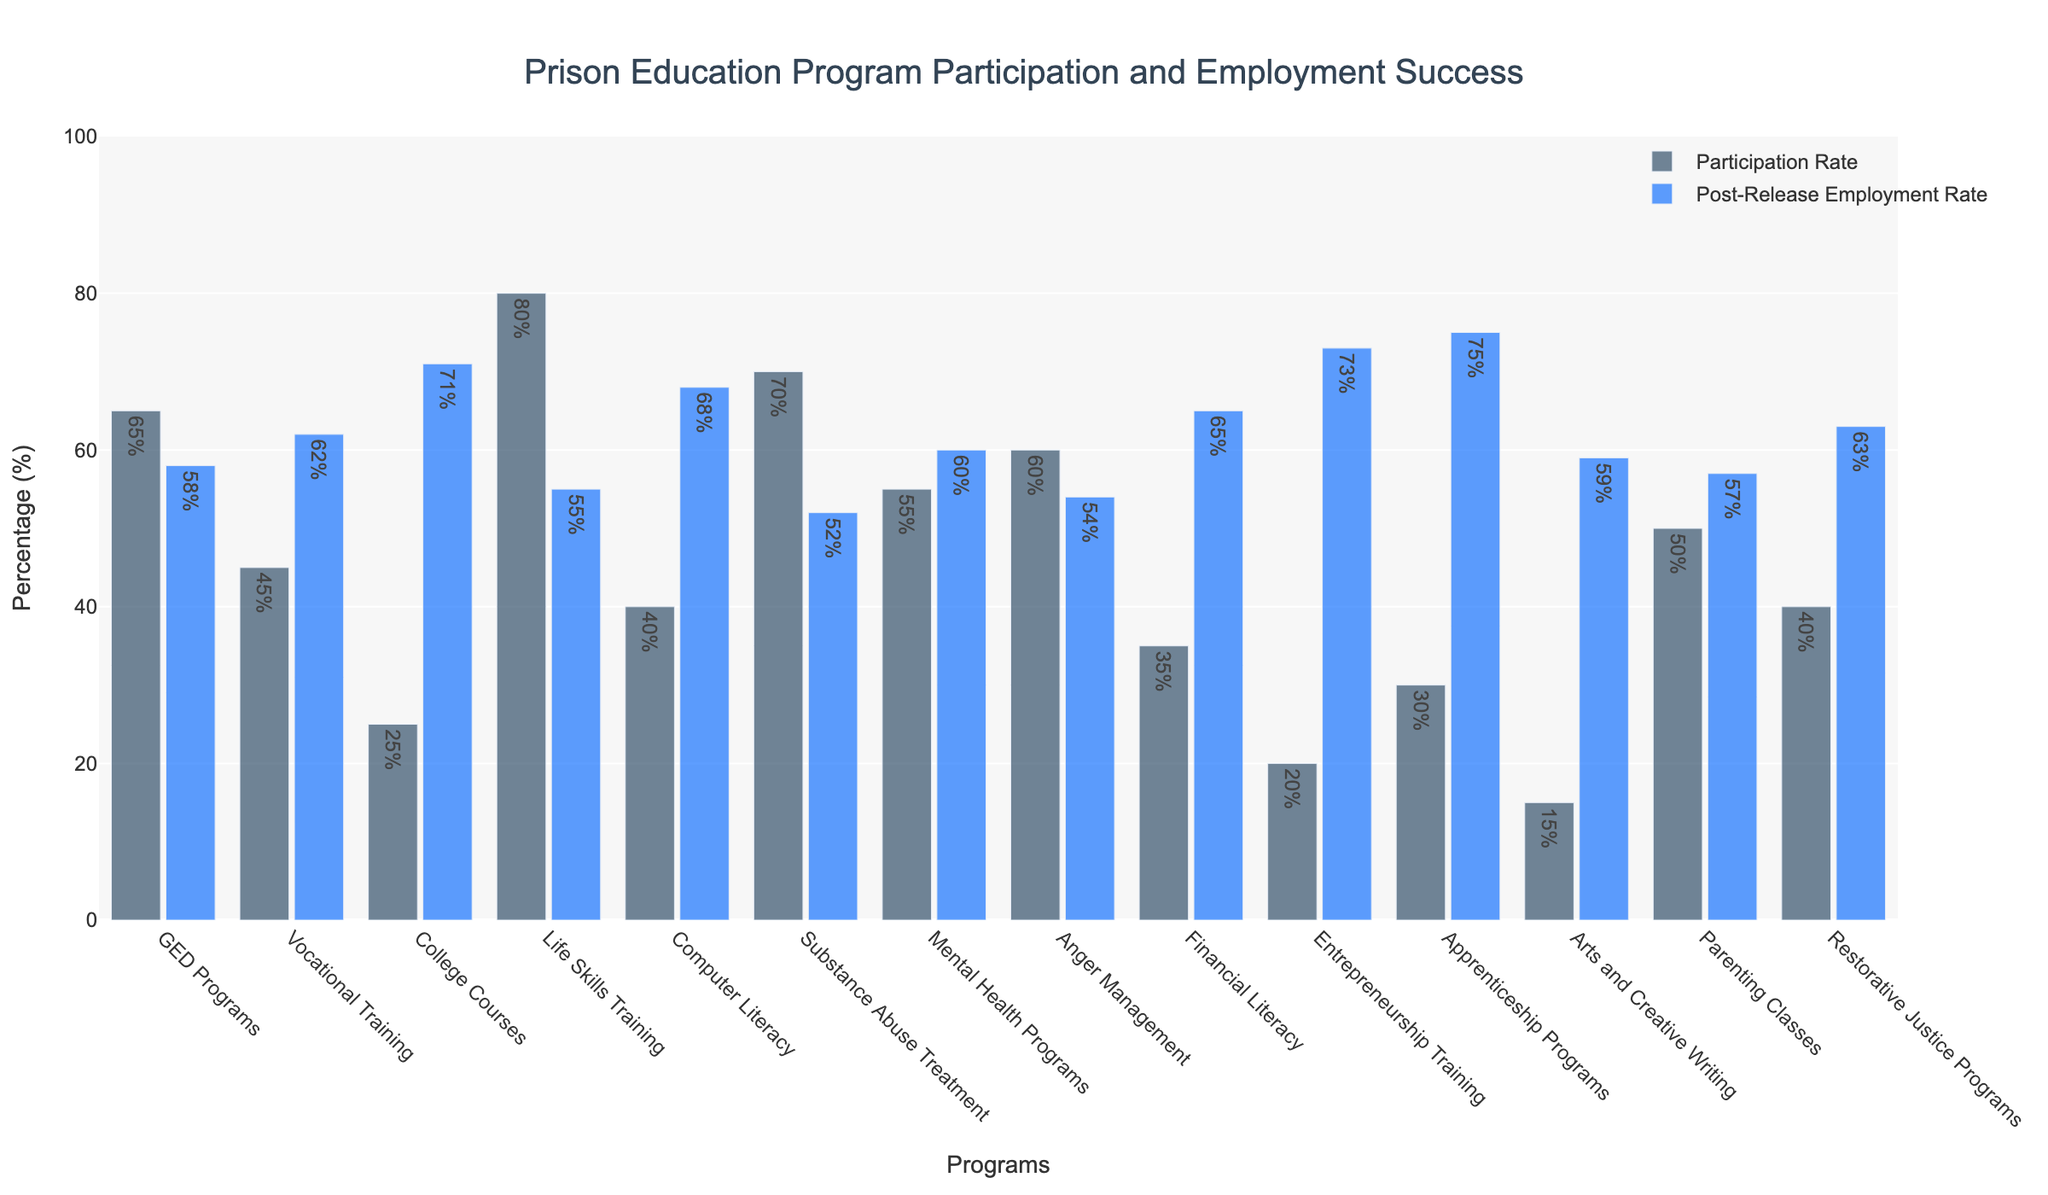Which program has the highest participation rate? The highest bar in the participation rate category corresponds to Life Skills Training.
Answer: Life Skills Training Which program has the highest post-release employment rate? The highest bar in the post-release employment rate category corresponds to Apprenticeship Programs.
Answer: Apprenticeship Programs Compare the participation rates of Life Skills Training and Computer Literacy. Which one is higher and by how much? Life Skills Training has a participation rate of 80%, while Computer Literacy has 40%. The difference is 80% - 40% = 40%.
Answer: Life Skills Training by 40% What is the difference between the participation rate and post-release employment rate for Substance Abuse Treatment? The participation rate for Substance Abuse Treatment is 70%, and the post-release employment rate is 52%. The difference is 70% - 52% = 18%.
Answer: 18% Which program has a higher post-release employment rate: GED Programs or Financial Literacy? The post-release employment rate for GED Programs is 58%, and for Financial Literacy, it's 65%. Financial Literacy has a higher rate.
Answer: Financial Literacy Find the average participation rate of College Courses, Computer Literacy, and Arts and Creative Writing. The participation rates are 25%, 40%, and 15% respectively. Their average is (25% + 40% + 15%) / 3 = 80% / 3 ≈ 26.67%.
Answer: 26.67% What is the median post-release employment rate of the programs sorted by participation rate? Sorted participation rates result in the following post-release employment rates: 59, 54, 55, 57, 52, 60, 54, 68, 55, 62, 57, 63, 71, 73, 75. The median is the middle value, which is the 8th value in this ordered list: 60.
Answer: 60 What is the total participation rate of all programs combined? Sum all participation rates: 65% + 45% + 25% + 80% + 40% + 70% + 55% + 60% + 35% + 20% + 30% + 15% + 50% + 40% = 630%.
Answer: 630% Which program shows a lower participation rate than Anger Management but a higher post-release employment rate? The participation rate for Anger Management is 60%. Computer Literacy has a lower participation rate at 40% but a higher post-release employment rate at 68%.
Answer: Computer Literacy Compare the post-release employment rates between Vocational Training and Restorative Justice Programs. Which one is higher and by how much? Vocational Training has a post-release employment rate of 62%, and Restorative Justice Programs have 63%. The difference is 63% - 62% = 1%.
Answer: Restorative Justice Programs by 1% 